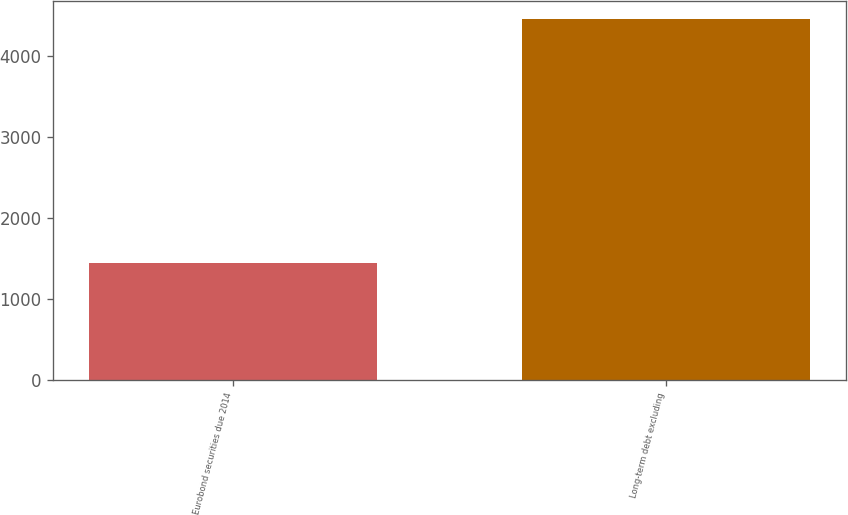<chart> <loc_0><loc_0><loc_500><loc_500><bar_chart><fcel>Eurobond securities due 2014<fcel>Long-term debt excluding<nl><fcel>1447<fcel>4463<nl></chart> 